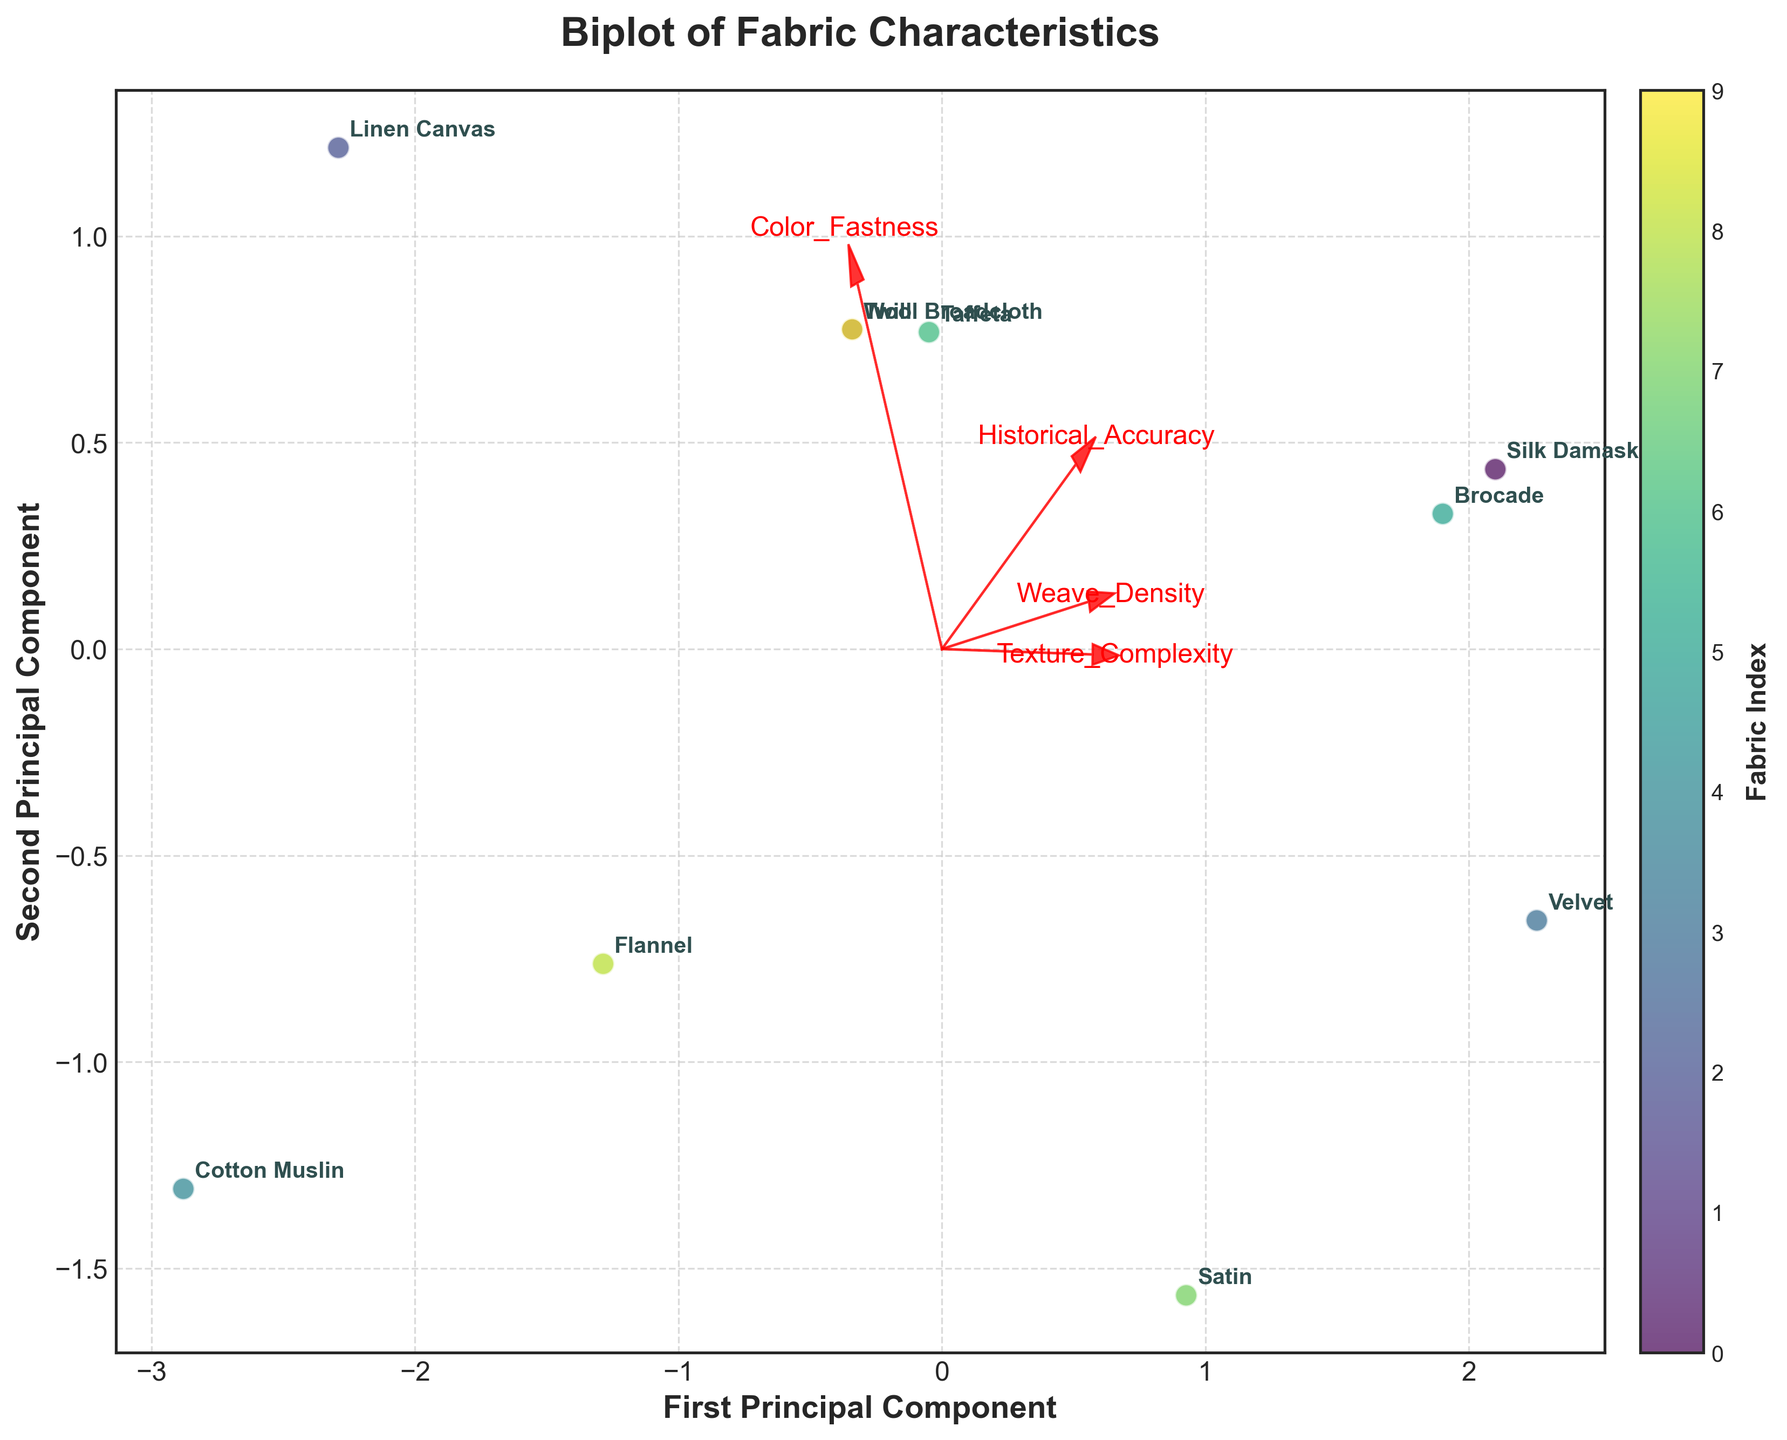Which fabric is the most correlated with high historical accuracy and high weave density? By looking at the directions of the Weave_Density and Historical_Accuracy vectors, we can see which fabrics are positioned closer to these vectors. Brocade and Velvet align closely with these vectors.
Answer: Brocade and Velvet Which fabric shows the highest texture complexity? The fabric located closest to the arrow labeled Texture_Complexity pointing towards higher values indicates high texture complexity. Velvet and Brocade are positioned close to this arrow.
Answer: Velvet and Brocade Which fabric appears to be the least distinctive in terms of both principal components? The fabric closest to the origin (0,0) of the plot will have the least distinction in terms of PCA dimensions. Cotton Muslin appears to be closest to the center.
Answer: Cotton Muslin Are there any fabrics with similar scores for both principal components? By observing fabrics that have points closely aligned along a diagonal line through the origin, we can identify ones with similar scores. Wool Broadcloth and Twill are quite close to each other, suggesting similar PCA scores.
Answer: Wool Broadcloth and Twill How do Satin and Taffeta compare in terms of their principal component scores? By comparing their positions on the plot, we can see how they differ. Both are situated relatively close to each other, with minor differences on both principal components.
Answer: Similar position, minor differences Which fabric scores high in the second principal component but lower in the first? A fabric positioned higher on the y-axis but not far along the x-axis would fit this description. Linen Canvas is high on the second component but closer to zero on the first.
Answer: Linen Canvas Do higher texture complexity and color fastness seem correlated? If these vectors point in similar directions or fabrics with high Texture_Complexity also have high Color_Fastness, they are correlated. Both vectors point in a similar direction, suggesting a correlation.
Answer: Yes What does the relative position of Silk Damask tell us about its characteristics in terms of the given features? Silk Damask's position relative to the feature vectors such as historical accuracy, weave density, and color fastness can be looked at to understand this. It's far from Historical_Accuracy and Color_Fastness, indicating it might have moderate to high values in those features.
Answer: Moderate to high in various features Which fabric could potentially have the lowest weave density? By looking at the opposite direction from the Weave_Density vector, the fabric furthest in that direction will have the lowest weave density. Cotton Muslin appears to be positioned opposite the vector.
Answer: Cotton Muslin Do any fabrics appear to have very similar total principal component scores when added (First PC + Second PC)? Summarizing the PC scores (both x and y coordinates) for each fabric and comparing them can show similarities. Wool Broadcloth and Twill, having close positions on the plot, would have similar summed scores.
Answer: Wool Broadcloth and Twill 